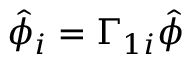<formula> <loc_0><loc_0><loc_500><loc_500>\hat { \phi } _ { i } = \Gamma _ { 1 i } \hat { \phi }</formula> 